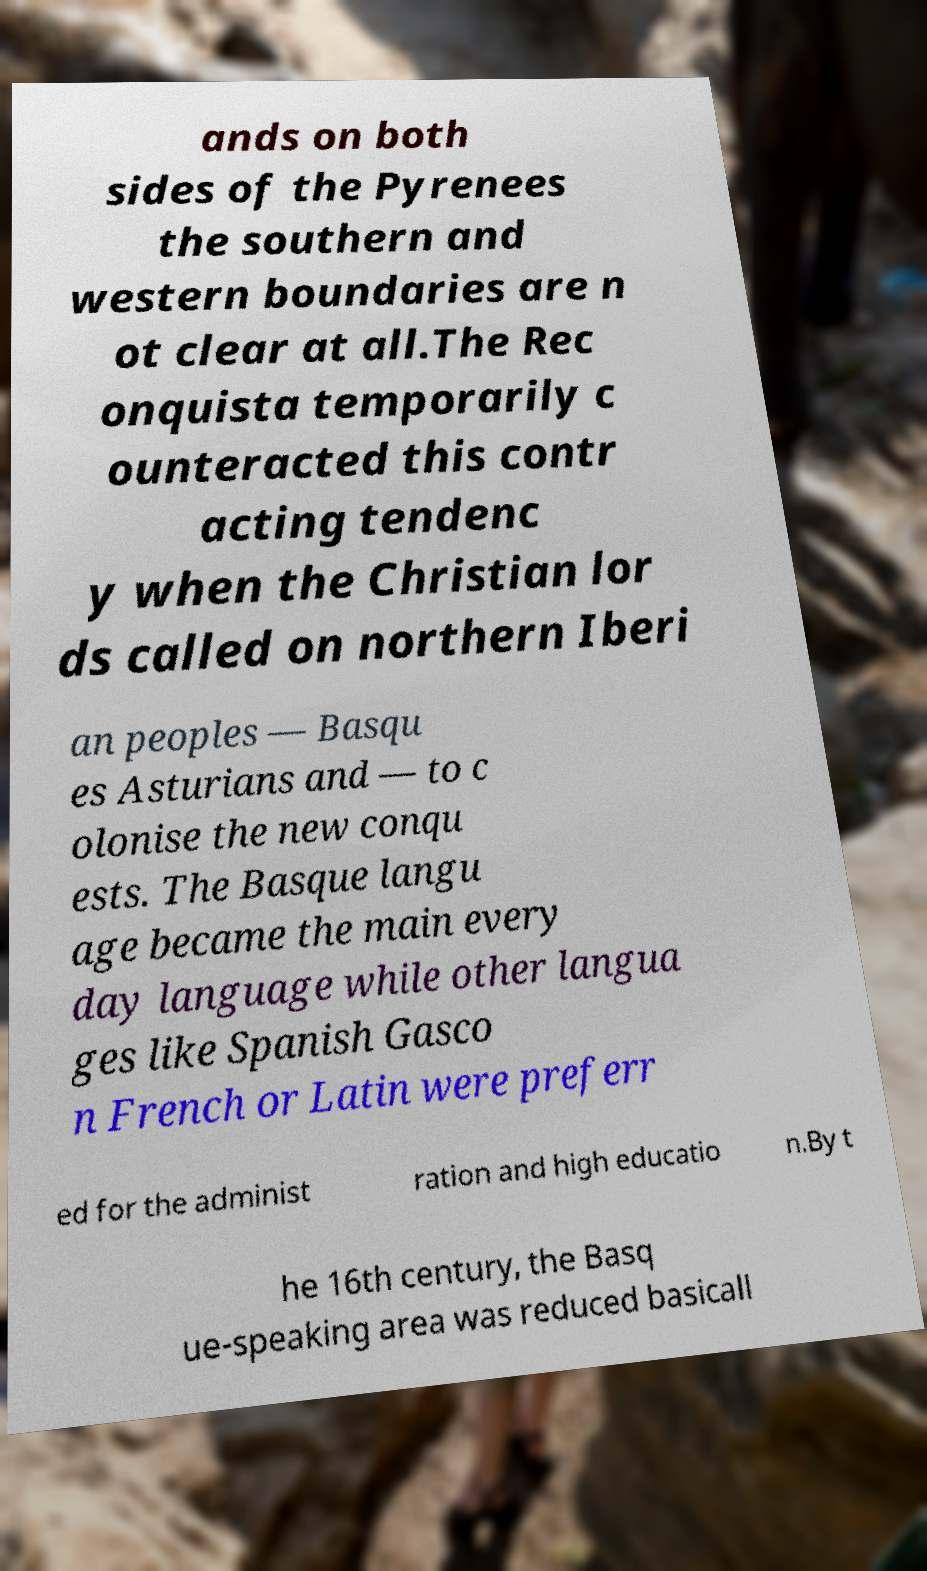Please read and relay the text visible in this image. What does it say? ands on both sides of the Pyrenees the southern and western boundaries are n ot clear at all.The Rec onquista temporarily c ounteracted this contr acting tendenc y when the Christian lor ds called on northern Iberi an peoples — Basqu es Asturians and — to c olonise the new conqu ests. The Basque langu age became the main every day language while other langua ges like Spanish Gasco n French or Latin were preferr ed for the administ ration and high educatio n.By t he 16th century, the Basq ue-speaking area was reduced basicall 